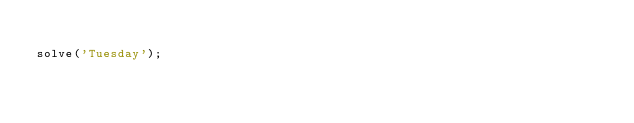Convert code to text. <code><loc_0><loc_0><loc_500><loc_500><_JavaScript_>
solve('Tuesday');
</code> 